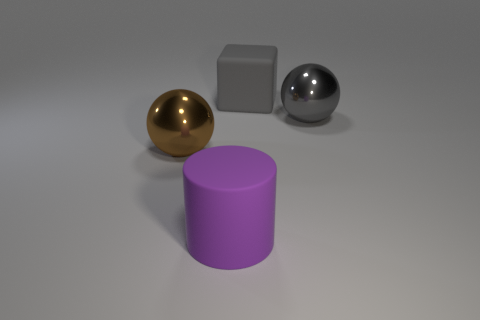Add 2 large cylinders. How many objects exist? 6 Subtract all cylinders. How many objects are left? 3 Subtract 0 gray cylinders. How many objects are left? 4 Subtract all cyan metallic things. Subtract all rubber cylinders. How many objects are left? 3 Add 3 big purple cylinders. How many big purple cylinders are left? 4 Add 3 purple metallic objects. How many purple metallic objects exist? 3 